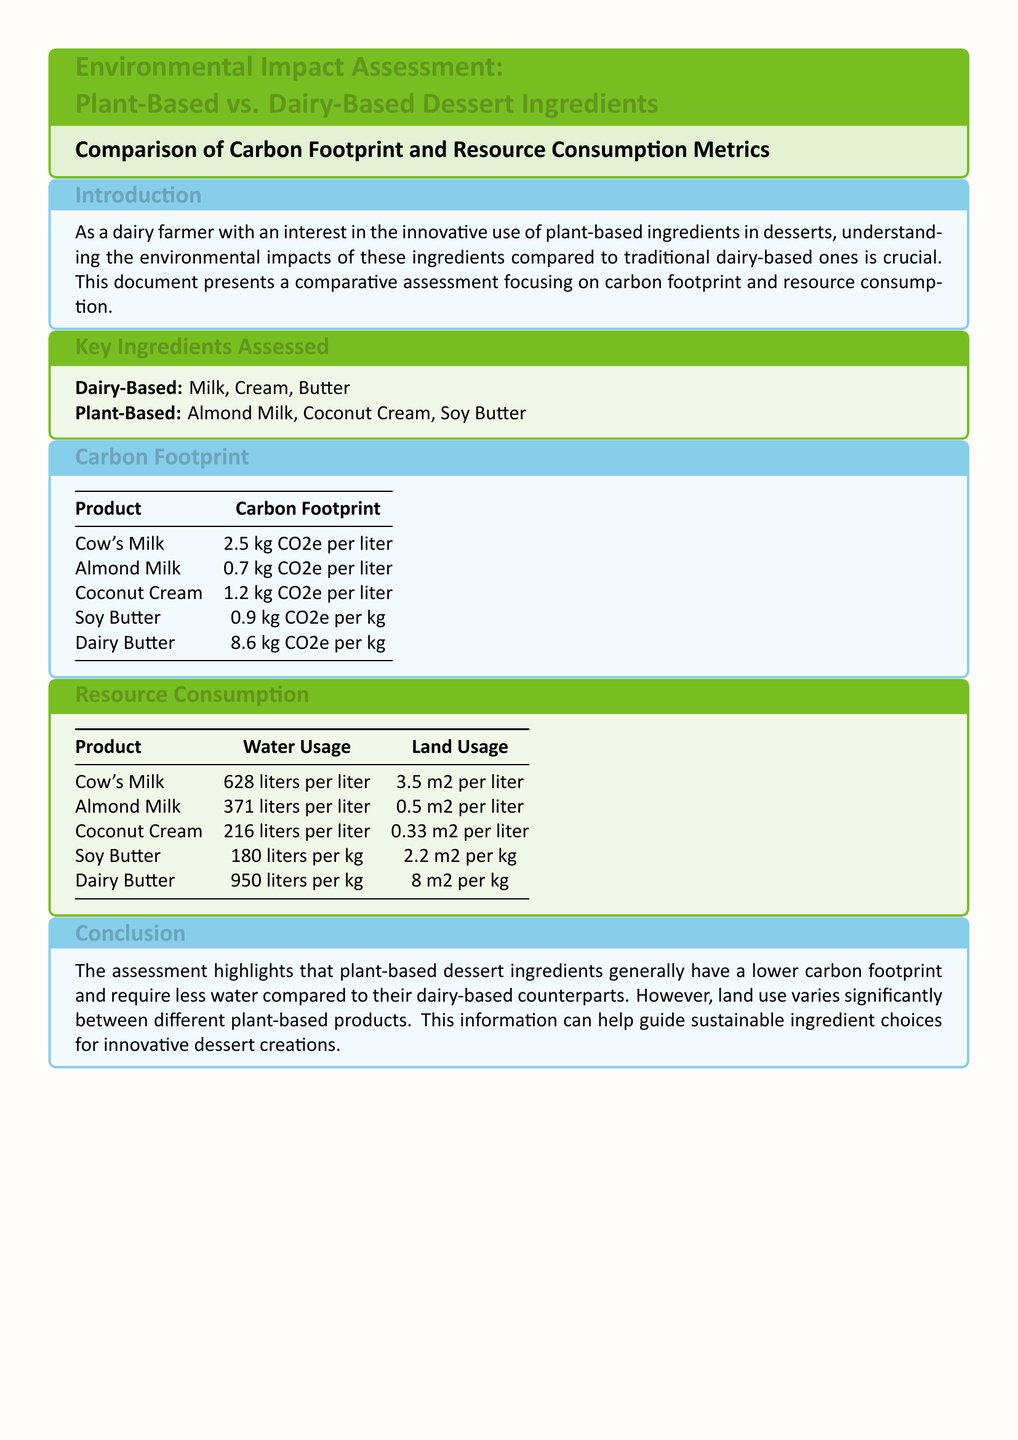what is the carbon footprint of Cow's Milk? The carbon footprint of Cow's Milk is presented in the carbon footprint section of the document, which states it is 2.5 kg CO2e per liter.
Answer: 2.5 kg CO2e per liter what is the water usage for Dairy Butter? The water usage for Dairy Butter is provided in the resource consumption section of the document, which lists it as 950 liters per kg.
Answer: 950 liters per kg which plant-based ingredient has the lowest carbon footprint? The carbon footprint table indicates that Almond Milk has the lowest carbon footprint among the listed plant-based products at 0.7 kg CO2e per liter.
Answer: Almond Milk how much land does Coconut Cream use? The document specifies the land usage for Coconut Cream as 0.33 m2 per liter in the resource consumption section.
Answer: 0.33 m2 per liter which dairy ingredient has the highest water usage? The resource consumption section shows that Dairy Butter has the highest water usage at 950 liters per kg.
Answer: Dairy Butter compare the land usage of Almond Milk and Soy Butter. The document lists land usage for Almond Milk as 0.5 m2 per liter and for Soy Butter as 2.2 m2 per kg, requiring comparison between these two values.
Answer: Almond Milk: 0.5 m2 per liter; Soy Butter: 2.2 m2 per kg what are the key dairy-based ingredients assessed? The key ingredients assessed section lists Milk, Cream, and Butter as the dairy-based ingredients.
Answer: Milk, Cream, Butter how does the carbon footprint of Soy Butter compare to that of Dairy Butter? The carbon footprint table shows Soy Butter with 0.9 kg CO2e per kg and Dairy Butter with 8.6 kg CO2e per kg, requiring comparison of these two figures.
Answer: Soy Butter: 0.9 kg CO2e per kg; Dairy Butter: 8.6 kg CO2e per kg what conclusion does the document draw about plant-based dessert ingredients? The conclusion section states that plant-based dessert ingredients generally have a lower carbon footprint and require less water compared to dairy-based ones.
Answer: Lower carbon footprint and less water usage 